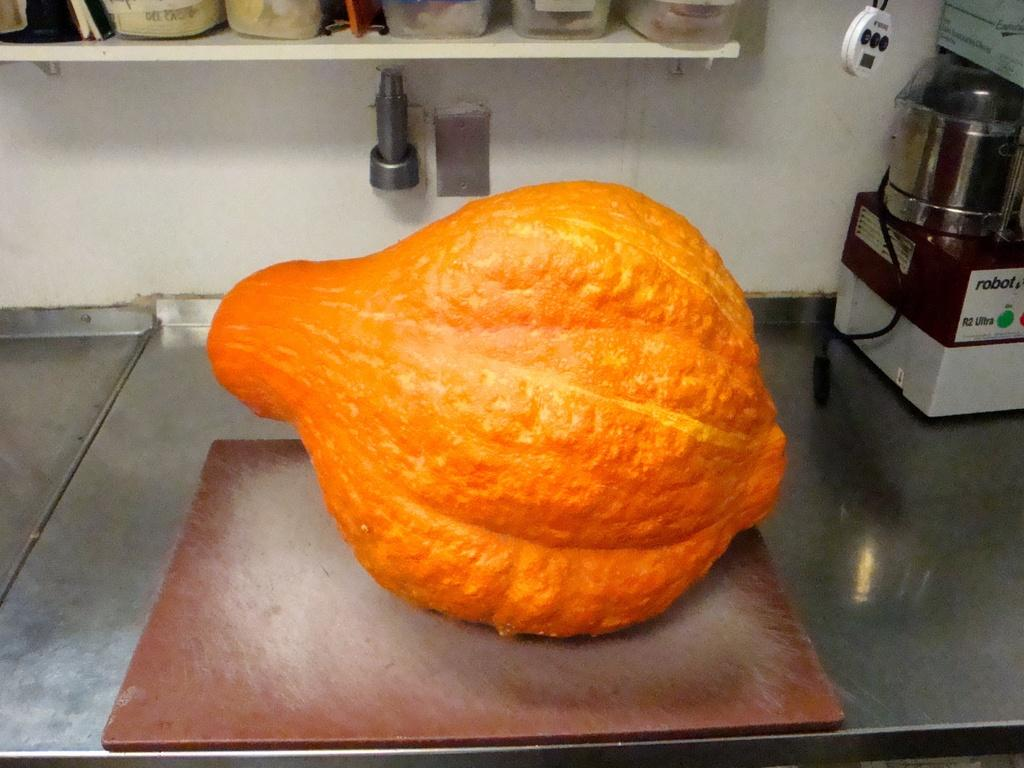<image>
Summarize the visual content of the image. A large orange squash type plant on a counter next to a Robot R2 Ultra device. 